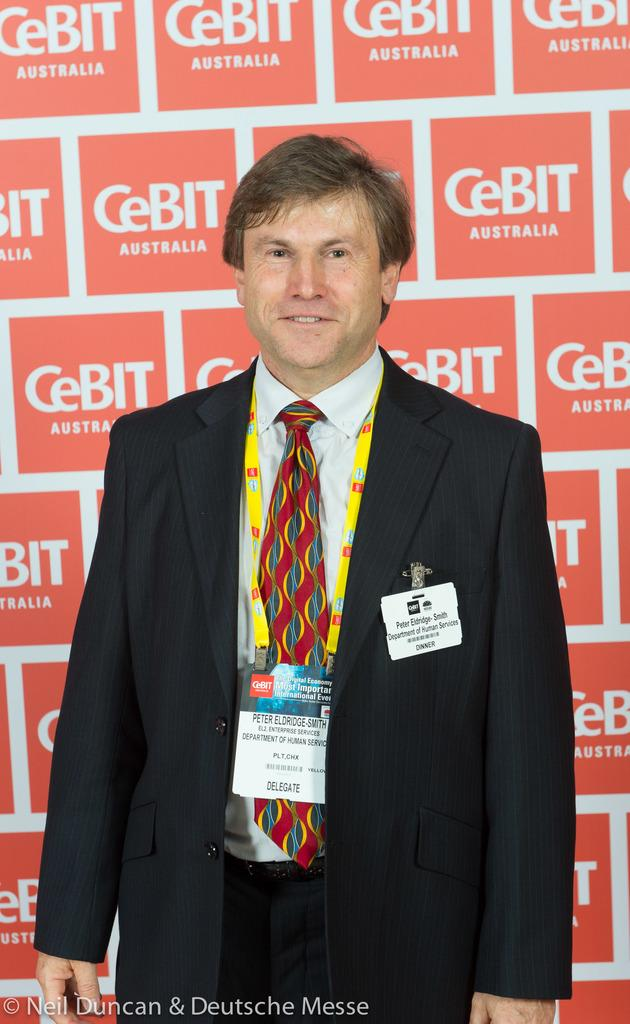Who is in the image? There is a man in the image. What is the man wearing? The man is wearing a black coat, a white shirt, and a red tie. Does the man have any identification in the image? Yes, the man has an identity card. What can be seen in the background of the image? There is a wall with text in the background of the image. Can you see any frogs or bushes in the image? No, there are no frogs or bushes present in the image. What achievement is the man celebrating in the image? The image does not provide any information about the man's achievements, so it cannot be determined from the image. 